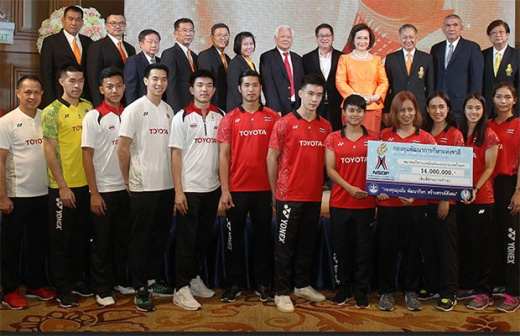Can you create a detailed story about the individuals holding the check? In a bustling city in Thailand, Supachai and Ananya emerged as the city's most promising badminton players. Their journey to this moment began in a humble neighborhood, with dreams fueled by a shared old racket and intense practice sessions in a makeshift court. Recognized for their talent, they received sponsorship from Toyota, which allowed them to train at state-of-the-art facilities and compete internationally. The 16,000,000 Thai Baht check they hold is not just a sponsorship; it's a testament to their hard work and the hopes and aspirations of countless young athletes from their hometown. Their smiles as they hold the check reflect not only pride in their achievements but also gratitude for the opportunity to inspire the next generation. With this check, they plan to start a foundation to support budding athletes from underprivileged backgrounds, ensuring that talent never goes unnoticed due to lack of resources. In what ways might the supported athletes help their community in return? The supported athletes, empowered by the opportunities given to them, can contribute to their community in numerous ways. They could set up training camps and workshops for local children, sharing their skills and fostering a new generation of athletes. Their success stories would serve as powerful inspiration, encouraging young people to pursue their passions. Furthermore, they might engage in community service projects, improving local sports facilities, organizing sports events, and promoting healthy lifestyles. Their visibility and influence could attract additional investments and support for the community, creating a ripple effect of positive change. 